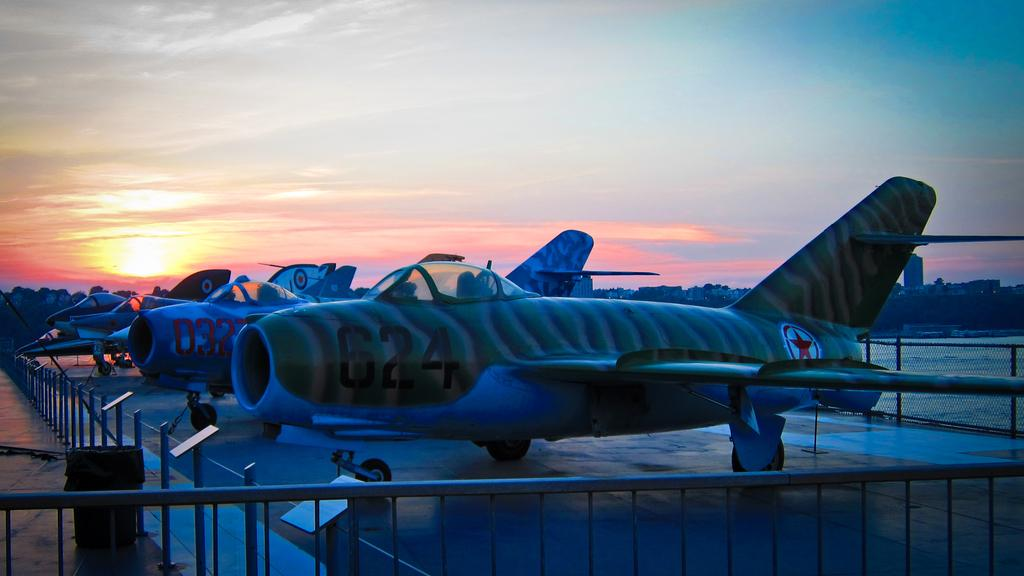<image>
Create a compact narrative representing the image presented. An airplane numbered 624 is first in a row of similar aircraft. 